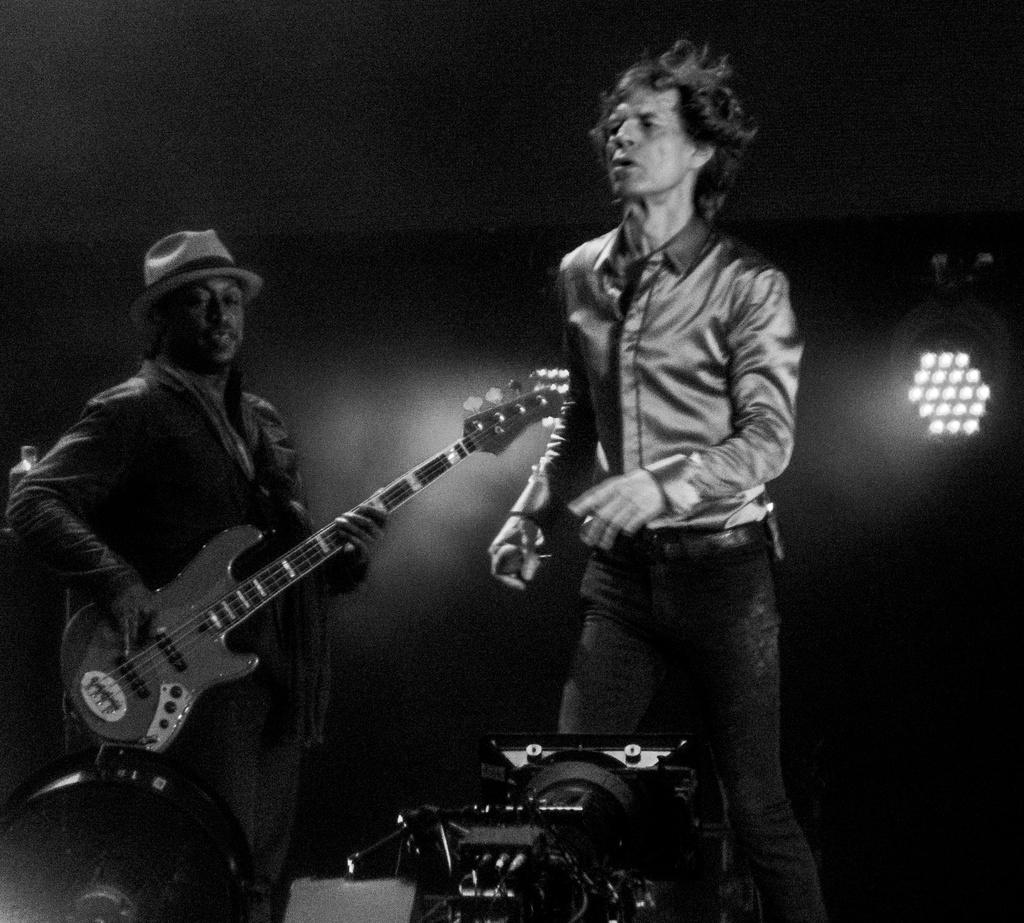What is the color scheme of the image? The image is black and white. How many people are in the image? There are two persons in the image. What is one person doing in the image? One person is playing a guitar. Can you describe the appearance of the person playing the guitar? The person playing the guitar is wearing a cap. How would you describe the lighting in the image? The image appears to be well-lit. What is the price of the guitar in the image? There is no price mentioned or visible in the image, as it is a black and white photograph. How does the person playing the guitar grip the instrument? The image does not show the person's grip on the guitar, so it cannot be determined from the image. 